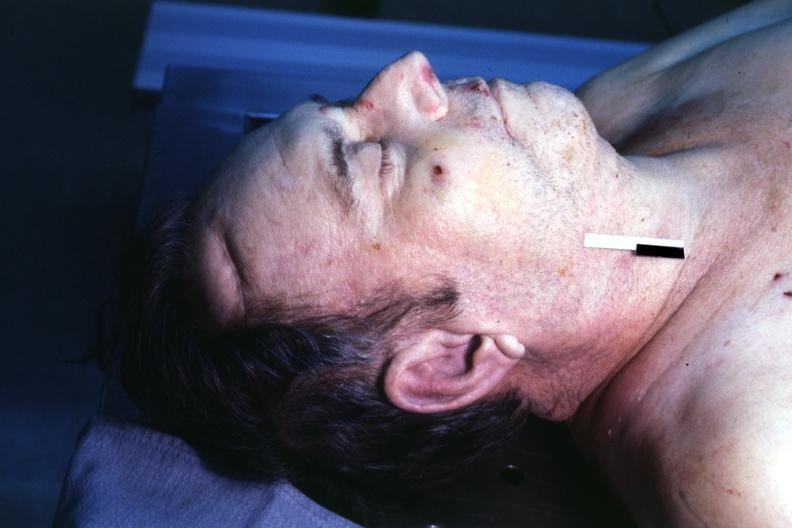s ear lobe horizontal crease present?
Answer the question using a single word or phrase. Yes 